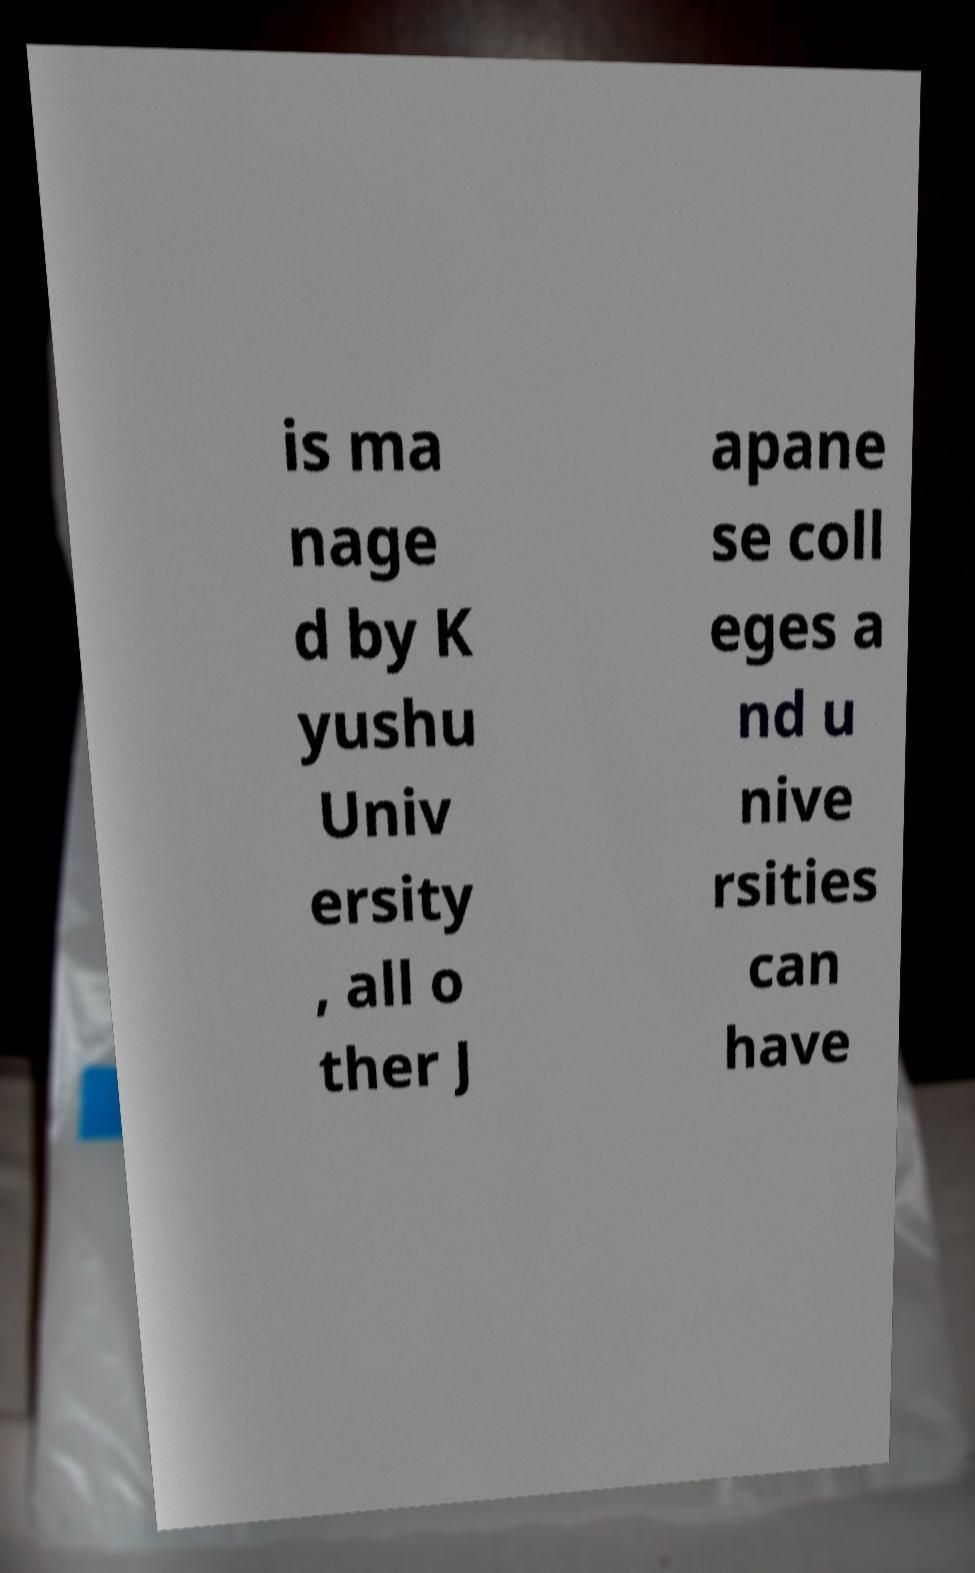Can you read and provide the text displayed in the image?This photo seems to have some interesting text. Can you extract and type it out for me? is ma nage d by K yushu Univ ersity , all o ther J apane se coll eges a nd u nive rsities can have 